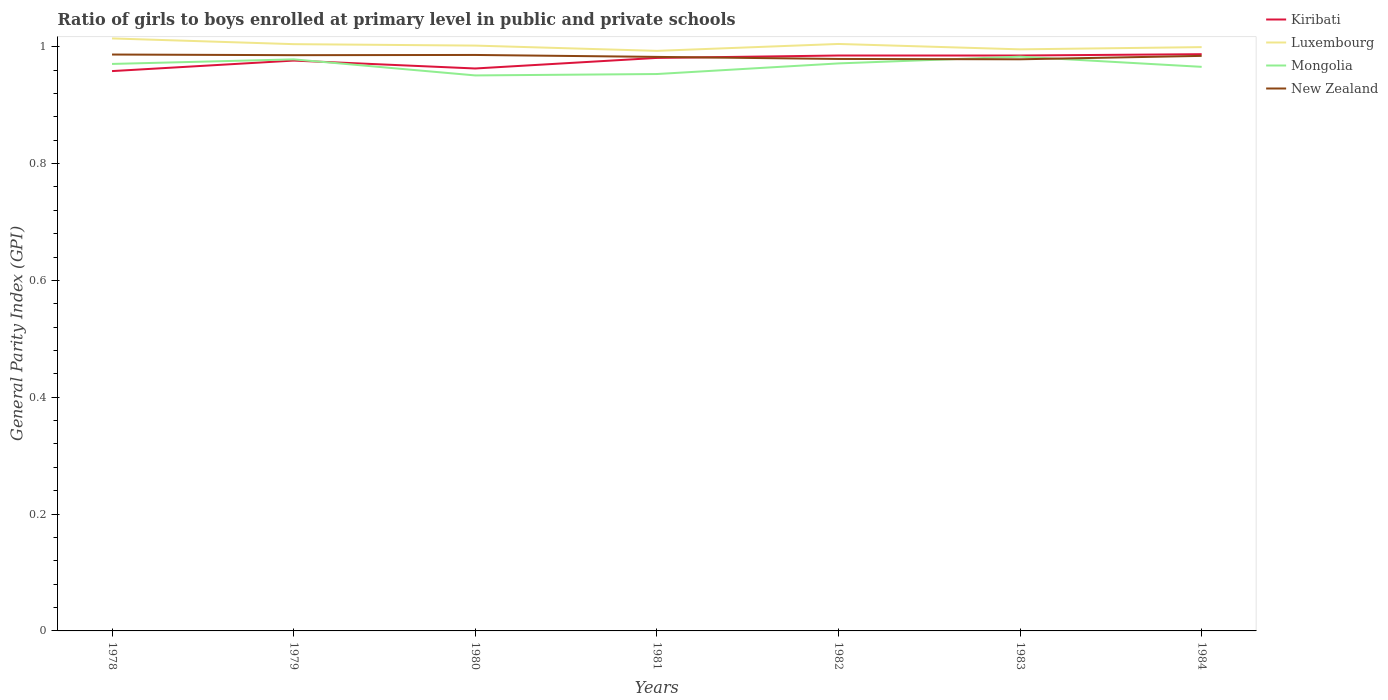How many different coloured lines are there?
Offer a very short reply. 4. Is the number of lines equal to the number of legend labels?
Your answer should be very brief. Yes. Across all years, what is the maximum general parity index in Kiribati?
Your response must be concise. 0.96. What is the total general parity index in Kiribati in the graph?
Keep it short and to the point. -0.03. What is the difference between the highest and the second highest general parity index in Luxembourg?
Give a very brief answer. 0.02. Is the general parity index in New Zealand strictly greater than the general parity index in Kiribati over the years?
Offer a terse response. No. How many lines are there?
Your response must be concise. 4. How many years are there in the graph?
Give a very brief answer. 7. Are the values on the major ticks of Y-axis written in scientific E-notation?
Ensure brevity in your answer.  No. Does the graph contain any zero values?
Ensure brevity in your answer.  No. How many legend labels are there?
Keep it short and to the point. 4. What is the title of the graph?
Offer a very short reply. Ratio of girls to boys enrolled at primary level in public and private schools. Does "Sierra Leone" appear as one of the legend labels in the graph?
Ensure brevity in your answer.  No. What is the label or title of the Y-axis?
Give a very brief answer. General Parity Index (GPI). What is the General Parity Index (GPI) of Kiribati in 1978?
Provide a succinct answer. 0.96. What is the General Parity Index (GPI) of Luxembourg in 1978?
Your answer should be compact. 1.01. What is the General Parity Index (GPI) in Mongolia in 1978?
Your response must be concise. 0.97. What is the General Parity Index (GPI) of New Zealand in 1978?
Provide a short and direct response. 0.99. What is the General Parity Index (GPI) in Kiribati in 1979?
Your answer should be compact. 0.98. What is the General Parity Index (GPI) in Luxembourg in 1979?
Offer a very short reply. 1. What is the General Parity Index (GPI) in Mongolia in 1979?
Your response must be concise. 0.98. What is the General Parity Index (GPI) of New Zealand in 1979?
Ensure brevity in your answer.  0.99. What is the General Parity Index (GPI) of Kiribati in 1980?
Keep it short and to the point. 0.96. What is the General Parity Index (GPI) in Luxembourg in 1980?
Offer a very short reply. 1. What is the General Parity Index (GPI) in Mongolia in 1980?
Your answer should be very brief. 0.95. What is the General Parity Index (GPI) of New Zealand in 1980?
Your answer should be compact. 0.99. What is the General Parity Index (GPI) of Kiribati in 1981?
Your answer should be compact. 0.98. What is the General Parity Index (GPI) of Luxembourg in 1981?
Offer a terse response. 0.99. What is the General Parity Index (GPI) in Mongolia in 1981?
Keep it short and to the point. 0.95. What is the General Parity Index (GPI) of New Zealand in 1981?
Your answer should be compact. 0.98. What is the General Parity Index (GPI) of Kiribati in 1982?
Make the answer very short. 0.98. What is the General Parity Index (GPI) of Luxembourg in 1982?
Keep it short and to the point. 1. What is the General Parity Index (GPI) in Mongolia in 1982?
Make the answer very short. 0.97. What is the General Parity Index (GPI) in New Zealand in 1982?
Your answer should be compact. 0.98. What is the General Parity Index (GPI) of Kiribati in 1983?
Make the answer very short. 0.98. What is the General Parity Index (GPI) of Luxembourg in 1983?
Make the answer very short. 1. What is the General Parity Index (GPI) in Mongolia in 1983?
Make the answer very short. 0.98. What is the General Parity Index (GPI) of New Zealand in 1983?
Keep it short and to the point. 0.98. What is the General Parity Index (GPI) of Kiribati in 1984?
Your response must be concise. 0.99. What is the General Parity Index (GPI) in Luxembourg in 1984?
Provide a succinct answer. 1. What is the General Parity Index (GPI) of Mongolia in 1984?
Provide a short and direct response. 0.97. What is the General Parity Index (GPI) in New Zealand in 1984?
Your answer should be compact. 0.98. Across all years, what is the maximum General Parity Index (GPI) in Kiribati?
Give a very brief answer. 0.99. Across all years, what is the maximum General Parity Index (GPI) in Luxembourg?
Give a very brief answer. 1.01. Across all years, what is the maximum General Parity Index (GPI) of Mongolia?
Ensure brevity in your answer.  0.98. Across all years, what is the maximum General Parity Index (GPI) in New Zealand?
Offer a terse response. 0.99. Across all years, what is the minimum General Parity Index (GPI) in Kiribati?
Your answer should be compact. 0.96. Across all years, what is the minimum General Parity Index (GPI) in Luxembourg?
Provide a succinct answer. 0.99. Across all years, what is the minimum General Parity Index (GPI) of Mongolia?
Offer a very short reply. 0.95. Across all years, what is the minimum General Parity Index (GPI) of New Zealand?
Your answer should be compact. 0.98. What is the total General Parity Index (GPI) of Kiribati in the graph?
Your answer should be compact. 6.83. What is the total General Parity Index (GPI) of Luxembourg in the graph?
Your response must be concise. 7.01. What is the total General Parity Index (GPI) in Mongolia in the graph?
Keep it short and to the point. 6.77. What is the total General Parity Index (GPI) in New Zealand in the graph?
Your answer should be very brief. 6.88. What is the difference between the General Parity Index (GPI) of Kiribati in 1978 and that in 1979?
Keep it short and to the point. -0.02. What is the difference between the General Parity Index (GPI) in Luxembourg in 1978 and that in 1979?
Your response must be concise. 0.01. What is the difference between the General Parity Index (GPI) of Mongolia in 1978 and that in 1979?
Make the answer very short. -0.01. What is the difference between the General Parity Index (GPI) of New Zealand in 1978 and that in 1979?
Your answer should be compact. 0. What is the difference between the General Parity Index (GPI) in Kiribati in 1978 and that in 1980?
Provide a short and direct response. -0. What is the difference between the General Parity Index (GPI) of Luxembourg in 1978 and that in 1980?
Offer a terse response. 0.01. What is the difference between the General Parity Index (GPI) of Mongolia in 1978 and that in 1980?
Your answer should be very brief. 0.02. What is the difference between the General Parity Index (GPI) in New Zealand in 1978 and that in 1980?
Your answer should be very brief. 0. What is the difference between the General Parity Index (GPI) of Kiribati in 1978 and that in 1981?
Ensure brevity in your answer.  -0.02. What is the difference between the General Parity Index (GPI) of Luxembourg in 1978 and that in 1981?
Your answer should be very brief. 0.02. What is the difference between the General Parity Index (GPI) of Mongolia in 1978 and that in 1981?
Provide a short and direct response. 0.02. What is the difference between the General Parity Index (GPI) of New Zealand in 1978 and that in 1981?
Your answer should be very brief. 0. What is the difference between the General Parity Index (GPI) in Kiribati in 1978 and that in 1982?
Your answer should be compact. -0.03. What is the difference between the General Parity Index (GPI) in Luxembourg in 1978 and that in 1982?
Keep it short and to the point. 0.01. What is the difference between the General Parity Index (GPI) in Mongolia in 1978 and that in 1982?
Give a very brief answer. -0. What is the difference between the General Parity Index (GPI) in New Zealand in 1978 and that in 1982?
Provide a short and direct response. 0.01. What is the difference between the General Parity Index (GPI) in Kiribati in 1978 and that in 1983?
Offer a terse response. -0.03. What is the difference between the General Parity Index (GPI) of Luxembourg in 1978 and that in 1983?
Offer a terse response. 0.02. What is the difference between the General Parity Index (GPI) of Mongolia in 1978 and that in 1983?
Your answer should be very brief. -0.01. What is the difference between the General Parity Index (GPI) of New Zealand in 1978 and that in 1983?
Your answer should be compact. 0.01. What is the difference between the General Parity Index (GPI) of Kiribati in 1978 and that in 1984?
Your answer should be compact. -0.03. What is the difference between the General Parity Index (GPI) of Luxembourg in 1978 and that in 1984?
Make the answer very short. 0.01. What is the difference between the General Parity Index (GPI) in Mongolia in 1978 and that in 1984?
Your answer should be compact. 0.01. What is the difference between the General Parity Index (GPI) of New Zealand in 1978 and that in 1984?
Offer a very short reply. 0. What is the difference between the General Parity Index (GPI) in Kiribati in 1979 and that in 1980?
Provide a short and direct response. 0.01. What is the difference between the General Parity Index (GPI) in Luxembourg in 1979 and that in 1980?
Give a very brief answer. 0. What is the difference between the General Parity Index (GPI) in Mongolia in 1979 and that in 1980?
Your answer should be compact. 0.03. What is the difference between the General Parity Index (GPI) of New Zealand in 1979 and that in 1980?
Offer a terse response. -0. What is the difference between the General Parity Index (GPI) of Kiribati in 1979 and that in 1981?
Your answer should be compact. -0. What is the difference between the General Parity Index (GPI) of Luxembourg in 1979 and that in 1981?
Your answer should be compact. 0.01. What is the difference between the General Parity Index (GPI) in Mongolia in 1979 and that in 1981?
Ensure brevity in your answer.  0.03. What is the difference between the General Parity Index (GPI) of New Zealand in 1979 and that in 1981?
Offer a very short reply. 0. What is the difference between the General Parity Index (GPI) of Kiribati in 1979 and that in 1982?
Provide a succinct answer. -0.01. What is the difference between the General Parity Index (GPI) in Luxembourg in 1979 and that in 1982?
Provide a short and direct response. -0. What is the difference between the General Parity Index (GPI) of Mongolia in 1979 and that in 1982?
Your response must be concise. 0.01. What is the difference between the General Parity Index (GPI) in New Zealand in 1979 and that in 1982?
Your response must be concise. 0.01. What is the difference between the General Parity Index (GPI) of Kiribati in 1979 and that in 1983?
Provide a short and direct response. -0.01. What is the difference between the General Parity Index (GPI) of Luxembourg in 1979 and that in 1983?
Provide a succinct answer. 0.01. What is the difference between the General Parity Index (GPI) of Mongolia in 1979 and that in 1983?
Provide a short and direct response. -0. What is the difference between the General Parity Index (GPI) in New Zealand in 1979 and that in 1983?
Ensure brevity in your answer.  0.01. What is the difference between the General Parity Index (GPI) of Kiribati in 1979 and that in 1984?
Provide a short and direct response. -0.01. What is the difference between the General Parity Index (GPI) in Luxembourg in 1979 and that in 1984?
Your answer should be very brief. 0.01. What is the difference between the General Parity Index (GPI) of Mongolia in 1979 and that in 1984?
Keep it short and to the point. 0.01. What is the difference between the General Parity Index (GPI) in New Zealand in 1979 and that in 1984?
Provide a short and direct response. 0. What is the difference between the General Parity Index (GPI) of Kiribati in 1980 and that in 1981?
Offer a very short reply. -0.02. What is the difference between the General Parity Index (GPI) in Luxembourg in 1980 and that in 1981?
Your response must be concise. 0.01. What is the difference between the General Parity Index (GPI) of Mongolia in 1980 and that in 1981?
Give a very brief answer. -0. What is the difference between the General Parity Index (GPI) in New Zealand in 1980 and that in 1981?
Keep it short and to the point. 0. What is the difference between the General Parity Index (GPI) in Kiribati in 1980 and that in 1982?
Give a very brief answer. -0.02. What is the difference between the General Parity Index (GPI) in Luxembourg in 1980 and that in 1982?
Keep it short and to the point. -0. What is the difference between the General Parity Index (GPI) of Mongolia in 1980 and that in 1982?
Make the answer very short. -0.02. What is the difference between the General Parity Index (GPI) of New Zealand in 1980 and that in 1982?
Provide a succinct answer. 0.01. What is the difference between the General Parity Index (GPI) of Kiribati in 1980 and that in 1983?
Offer a very short reply. -0.02. What is the difference between the General Parity Index (GPI) of Luxembourg in 1980 and that in 1983?
Give a very brief answer. 0.01. What is the difference between the General Parity Index (GPI) of Mongolia in 1980 and that in 1983?
Provide a succinct answer. -0.03. What is the difference between the General Parity Index (GPI) in New Zealand in 1980 and that in 1983?
Ensure brevity in your answer.  0.01. What is the difference between the General Parity Index (GPI) in Kiribati in 1980 and that in 1984?
Your answer should be very brief. -0.02. What is the difference between the General Parity Index (GPI) in Luxembourg in 1980 and that in 1984?
Offer a very short reply. 0. What is the difference between the General Parity Index (GPI) of Mongolia in 1980 and that in 1984?
Make the answer very short. -0.01. What is the difference between the General Parity Index (GPI) in New Zealand in 1980 and that in 1984?
Give a very brief answer. 0. What is the difference between the General Parity Index (GPI) of Kiribati in 1981 and that in 1982?
Your answer should be compact. -0. What is the difference between the General Parity Index (GPI) in Luxembourg in 1981 and that in 1982?
Give a very brief answer. -0.01. What is the difference between the General Parity Index (GPI) of Mongolia in 1981 and that in 1982?
Keep it short and to the point. -0.02. What is the difference between the General Parity Index (GPI) of New Zealand in 1981 and that in 1982?
Keep it short and to the point. 0. What is the difference between the General Parity Index (GPI) in Kiribati in 1981 and that in 1983?
Your response must be concise. -0. What is the difference between the General Parity Index (GPI) in Luxembourg in 1981 and that in 1983?
Keep it short and to the point. -0. What is the difference between the General Parity Index (GPI) in Mongolia in 1981 and that in 1983?
Ensure brevity in your answer.  -0.03. What is the difference between the General Parity Index (GPI) in New Zealand in 1981 and that in 1983?
Ensure brevity in your answer.  0. What is the difference between the General Parity Index (GPI) in Kiribati in 1981 and that in 1984?
Your answer should be compact. -0.01. What is the difference between the General Parity Index (GPI) of Luxembourg in 1981 and that in 1984?
Your answer should be compact. -0.01. What is the difference between the General Parity Index (GPI) of Mongolia in 1981 and that in 1984?
Your answer should be very brief. -0.01. What is the difference between the General Parity Index (GPI) in New Zealand in 1981 and that in 1984?
Make the answer very short. -0. What is the difference between the General Parity Index (GPI) of Kiribati in 1982 and that in 1983?
Your answer should be very brief. -0. What is the difference between the General Parity Index (GPI) in Luxembourg in 1982 and that in 1983?
Provide a succinct answer. 0.01. What is the difference between the General Parity Index (GPI) in Mongolia in 1982 and that in 1983?
Keep it short and to the point. -0.01. What is the difference between the General Parity Index (GPI) of New Zealand in 1982 and that in 1983?
Provide a short and direct response. 0. What is the difference between the General Parity Index (GPI) of Kiribati in 1982 and that in 1984?
Your answer should be very brief. -0. What is the difference between the General Parity Index (GPI) of Luxembourg in 1982 and that in 1984?
Your answer should be very brief. 0.01. What is the difference between the General Parity Index (GPI) of Mongolia in 1982 and that in 1984?
Offer a terse response. 0.01. What is the difference between the General Parity Index (GPI) of New Zealand in 1982 and that in 1984?
Provide a short and direct response. -0.01. What is the difference between the General Parity Index (GPI) of Kiribati in 1983 and that in 1984?
Offer a very short reply. -0. What is the difference between the General Parity Index (GPI) of Luxembourg in 1983 and that in 1984?
Your response must be concise. -0. What is the difference between the General Parity Index (GPI) in Mongolia in 1983 and that in 1984?
Offer a terse response. 0.02. What is the difference between the General Parity Index (GPI) in New Zealand in 1983 and that in 1984?
Keep it short and to the point. -0.01. What is the difference between the General Parity Index (GPI) of Kiribati in 1978 and the General Parity Index (GPI) of Luxembourg in 1979?
Offer a terse response. -0.05. What is the difference between the General Parity Index (GPI) of Kiribati in 1978 and the General Parity Index (GPI) of Mongolia in 1979?
Your answer should be compact. -0.02. What is the difference between the General Parity Index (GPI) of Kiribati in 1978 and the General Parity Index (GPI) of New Zealand in 1979?
Your response must be concise. -0.03. What is the difference between the General Parity Index (GPI) in Luxembourg in 1978 and the General Parity Index (GPI) in Mongolia in 1979?
Provide a succinct answer. 0.04. What is the difference between the General Parity Index (GPI) in Luxembourg in 1978 and the General Parity Index (GPI) in New Zealand in 1979?
Offer a very short reply. 0.03. What is the difference between the General Parity Index (GPI) of Mongolia in 1978 and the General Parity Index (GPI) of New Zealand in 1979?
Your response must be concise. -0.01. What is the difference between the General Parity Index (GPI) of Kiribati in 1978 and the General Parity Index (GPI) of Luxembourg in 1980?
Ensure brevity in your answer.  -0.04. What is the difference between the General Parity Index (GPI) of Kiribati in 1978 and the General Parity Index (GPI) of Mongolia in 1980?
Provide a short and direct response. 0.01. What is the difference between the General Parity Index (GPI) in Kiribati in 1978 and the General Parity Index (GPI) in New Zealand in 1980?
Offer a very short reply. -0.03. What is the difference between the General Parity Index (GPI) of Luxembourg in 1978 and the General Parity Index (GPI) of Mongolia in 1980?
Your answer should be very brief. 0.06. What is the difference between the General Parity Index (GPI) of Luxembourg in 1978 and the General Parity Index (GPI) of New Zealand in 1980?
Your answer should be very brief. 0.03. What is the difference between the General Parity Index (GPI) in Mongolia in 1978 and the General Parity Index (GPI) in New Zealand in 1980?
Your answer should be very brief. -0.02. What is the difference between the General Parity Index (GPI) of Kiribati in 1978 and the General Parity Index (GPI) of Luxembourg in 1981?
Your answer should be very brief. -0.03. What is the difference between the General Parity Index (GPI) of Kiribati in 1978 and the General Parity Index (GPI) of Mongolia in 1981?
Provide a short and direct response. 0.01. What is the difference between the General Parity Index (GPI) in Kiribati in 1978 and the General Parity Index (GPI) in New Zealand in 1981?
Give a very brief answer. -0.02. What is the difference between the General Parity Index (GPI) of Luxembourg in 1978 and the General Parity Index (GPI) of Mongolia in 1981?
Ensure brevity in your answer.  0.06. What is the difference between the General Parity Index (GPI) of Luxembourg in 1978 and the General Parity Index (GPI) of New Zealand in 1981?
Keep it short and to the point. 0.03. What is the difference between the General Parity Index (GPI) of Mongolia in 1978 and the General Parity Index (GPI) of New Zealand in 1981?
Make the answer very short. -0.01. What is the difference between the General Parity Index (GPI) of Kiribati in 1978 and the General Parity Index (GPI) of Luxembourg in 1982?
Your answer should be very brief. -0.05. What is the difference between the General Parity Index (GPI) of Kiribati in 1978 and the General Parity Index (GPI) of Mongolia in 1982?
Keep it short and to the point. -0.01. What is the difference between the General Parity Index (GPI) in Kiribati in 1978 and the General Parity Index (GPI) in New Zealand in 1982?
Your response must be concise. -0.02. What is the difference between the General Parity Index (GPI) of Luxembourg in 1978 and the General Parity Index (GPI) of Mongolia in 1982?
Your answer should be very brief. 0.04. What is the difference between the General Parity Index (GPI) in Luxembourg in 1978 and the General Parity Index (GPI) in New Zealand in 1982?
Offer a very short reply. 0.04. What is the difference between the General Parity Index (GPI) of Mongolia in 1978 and the General Parity Index (GPI) of New Zealand in 1982?
Offer a terse response. -0.01. What is the difference between the General Parity Index (GPI) of Kiribati in 1978 and the General Parity Index (GPI) of Luxembourg in 1983?
Offer a terse response. -0.04. What is the difference between the General Parity Index (GPI) of Kiribati in 1978 and the General Parity Index (GPI) of Mongolia in 1983?
Give a very brief answer. -0.02. What is the difference between the General Parity Index (GPI) of Kiribati in 1978 and the General Parity Index (GPI) of New Zealand in 1983?
Keep it short and to the point. -0.02. What is the difference between the General Parity Index (GPI) of Luxembourg in 1978 and the General Parity Index (GPI) of Mongolia in 1983?
Your answer should be very brief. 0.03. What is the difference between the General Parity Index (GPI) in Luxembourg in 1978 and the General Parity Index (GPI) in New Zealand in 1983?
Ensure brevity in your answer.  0.04. What is the difference between the General Parity Index (GPI) of Mongolia in 1978 and the General Parity Index (GPI) of New Zealand in 1983?
Provide a succinct answer. -0.01. What is the difference between the General Parity Index (GPI) of Kiribati in 1978 and the General Parity Index (GPI) of Luxembourg in 1984?
Your answer should be compact. -0.04. What is the difference between the General Parity Index (GPI) of Kiribati in 1978 and the General Parity Index (GPI) of Mongolia in 1984?
Ensure brevity in your answer.  -0.01. What is the difference between the General Parity Index (GPI) in Kiribati in 1978 and the General Parity Index (GPI) in New Zealand in 1984?
Offer a terse response. -0.03. What is the difference between the General Parity Index (GPI) of Luxembourg in 1978 and the General Parity Index (GPI) of Mongolia in 1984?
Offer a terse response. 0.05. What is the difference between the General Parity Index (GPI) of Luxembourg in 1978 and the General Parity Index (GPI) of New Zealand in 1984?
Provide a short and direct response. 0.03. What is the difference between the General Parity Index (GPI) of Mongolia in 1978 and the General Parity Index (GPI) of New Zealand in 1984?
Your response must be concise. -0.01. What is the difference between the General Parity Index (GPI) in Kiribati in 1979 and the General Parity Index (GPI) in Luxembourg in 1980?
Provide a succinct answer. -0.03. What is the difference between the General Parity Index (GPI) in Kiribati in 1979 and the General Parity Index (GPI) in Mongolia in 1980?
Offer a very short reply. 0.03. What is the difference between the General Parity Index (GPI) in Kiribati in 1979 and the General Parity Index (GPI) in New Zealand in 1980?
Your answer should be compact. -0.01. What is the difference between the General Parity Index (GPI) in Luxembourg in 1979 and the General Parity Index (GPI) in Mongolia in 1980?
Your response must be concise. 0.05. What is the difference between the General Parity Index (GPI) of Luxembourg in 1979 and the General Parity Index (GPI) of New Zealand in 1980?
Provide a succinct answer. 0.02. What is the difference between the General Parity Index (GPI) of Mongolia in 1979 and the General Parity Index (GPI) of New Zealand in 1980?
Provide a succinct answer. -0.01. What is the difference between the General Parity Index (GPI) of Kiribati in 1979 and the General Parity Index (GPI) of Luxembourg in 1981?
Provide a short and direct response. -0.02. What is the difference between the General Parity Index (GPI) of Kiribati in 1979 and the General Parity Index (GPI) of Mongolia in 1981?
Your response must be concise. 0.02. What is the difference between the General Parity Index (GPI) of Kiribati in 1979 and the General Parity Index (GPI) of New Zealand in 1981?
Offer a terse response. -0.01. What is the difference between the General Parity Index (GPI) of Luxembourg in 1979 and the General Parity Index (GPI) of Mongolia in 1981?
Your answer should be compact. 0.05. What is the difference between the General Parity Index (GPI) in Luxembourg in 1979 and the General Parity Index (GPI) in New Zealand in 1981?
Give a very brief answer. 0.02. What is the difference between the General Parity Index (GPI) of Mongolia in 1979 and the General Parity Index (GPI) of New Zealand in 1981?
Your answer should be very brief. -0. What is the difference between the General Parity Index (GPI) of Kiribati in 1979 and the General Parity Index (GPI) of Luxembourg in 1982?
Your answer should be compact. -0.03. What is the difference between the General Parity Index (GPI) of Kiribati in 1979 and the General Parity Index (GPI) of Mongolia in 1982?
Your response must be concise. 0. What is the difference between the General Parity Index (GPI) of Kiribati in 1979 and the General Parity Index (GPI) of New Zealand in 1982?
Offer a terse response. -0. What is the difference between the General Parity Index (GPI) in Luxembourg in 1979 and the General Parity Index (GPI) in Mongolia in 1982?
Your response must be concise. 0.03. What is the difference between the General Parity Index (GPI) of Luxembourg in 1979 and the General Parity Index (GPI) of New Zealand in 1982?
Offer a terse response. 0.03. What is the difference between the General Parity Index (GPI) of Mongolia in 1979 and the General Parity Index (GPI) of New Zealand in 1982?
Keep it short and to the point. -0. What is the difference between the General Parity Index (GPI) in Kiribati in 1979 and the General Parity Index (GPI) in Luxembourg in 1983?
Make the answer very short. -0.02. What is the difference between the General Parity Index (GPI) in Kiribati in 1979 and the General Parity Index (GPI) in Mongolia in 1983?
Provide a succinct answer. -0.01. What is the difference between the General Parity Index (GPI) in Kiribati in 1979 and the General Parity Index (GPI) in New Zealand in 1983?
Keep it short and to the point. -0. What is the difference between the General Parity Index (GPI) of Luxembourg in 1979 and the General Parity Index (GPI) of Mongolia in 1983?
Give a very brief answer. 0.02. What is the difference between the General Parity Index (GPI) of Luxembourg in 1979 and the General Parity Index (GPI) of New Zealand in 1983?
Offer a terse response. 0.03. What is the difference between the General Parity Index (GPI) in Mongolia in 1979 and the General Parity Index (GPI) in New Zealand in 1983?
Your answer should be very brief. -0. What is the difference between the General Parity Index (GPI) of Kiribati in 1979 and the General Parity Index (GPI) of Luxembourg in 1984?
Your answer should be compact. -0.02. What is the difference between the General Parity Index (GPI) in Kiribati in 1979 and the General Parity Index (GPI) in Mongolia in 1984?
Your answer should be very brief. 0.01. What is the difference between the General Parity Index (GPI) of Kiribati in 1979 and the General Parity Index (GPI) of New Zealand in 1984?
Ensure brevity in your answer.  -0.01. What is the difference between the General Parity Index (GPI) of Luxembourg in 1979 and the General Parity Index (GPI) of Mongolia in 1984?
Provide a succinct answer. 0.04. What is the difference between the General Parity Index (GPI) in Luxembourg in 1979 and the General Parity Index (GPI) in New Zealand in 1984?
Your response must be concise. 0.02. What is the difference between the General Parity Index (GPI) of Mongolia in 1979 and the General Parity Index (GPI) of New Zealand in 1984?
Provide a succinct answer. -0.01. What is the difference between the General Parity Index (GPI) of Kiribati in 1980 and the General Parity Index (GPI) of Luxembourg in 1981?
Your answer should be very brief. -0.03. What is the difference between the General Parity Index (GPI) in Kiribati in 1980 and the General Parity Index (GPI) in Mongolia in 1981?
Keep it short and to the point. 0.01. What is the difference between the General Parity Index (GPI) of Kiribati in 1980 and the General Parity Index (GPI) of New Zealand in 1981?
Keep it short and to the point. -0.02. What is the difference between the General Parity Index (GPI) in Luxembourg in 1980 and the General Parity Index (GPI) in Mongolia in 1981?
Give a very brief answer. 0.05. What is the difference between the General Parity Index (GPI) of Luxembourg in 1980 and the General Parity Index (GPI) of New Zealand in 1981?
Your answer should be very brief. 0.02. What is the difference between the General Parity Index (GPI) in Mongolia in 1980 and the General Parity Index (GPI) in New Zealand in 1981?
Your answer should be very brief. -0.03. What is the difference between the General Parity Index (GPI) in Kiribati in 1980 and the General Parity Index (GPI) in Luxembourg in 1982?
Offer a very short reply. -0.04. What is the difference between the General Parity Index (GPI) of Kiribati in 1980 and the General Parity Index (GPI) of Mongolia in 1982?
Keep it short and to the point. -0.01. What is the difference between the General Parity Index (GPI) of Kiribati in 1980 and the General Parity Index (GPI) of New Zealand in 1982?
Make the answer very short. -0.02. What is the difference between the General Parity Index (GPI) of Luxembourg in 1980 and the General Parity Index (GPI) of Mongolia in 1982?
Your answer should be very brief. 0.03. What is the difference between the General Parity Index (GPI) in Luxembourg in 1980 and the General Parity Index (GPI) in New Zealand in 1982?
Keep it short and to the point. 0.02. What is the difference between the General Parity Index (GPI) in Mongolia in 1980 and the General Parity Index (GPI) in New Zealand in 1982?
Your response must be concise. -0.03. What is the difference between the General Parity Index (GPI) in Kiribati in 1980 and the General Parity Index (GPI) in Luxembourg in 1983?
Your answer should be very brief. -0.03. What is the difference between the General Parity Index (GPI) of Kiribati in 1980 and the General Parity Index (GPI) of Mongolia in 1983?
Your answer should be very brief. -0.02. What is the difference between the General Parity Index (GPI) in Kiribati in 1980 and the General Parity Index (GPI) in New Zealand in 1983?
Provide a succinct answer. -0.02. What is the difference between the General Parity Index (GPI) of Luxembourg in 1980 and the General Parity Index (GPI) of Mongolia in 1983?
Give a very brief answer. 0.02. What is the difference between the General Parity Index (GPI) of Luxembourg in 1980 and the General Parity Index (GPI) of New Zealand in 1983?
Ensure brevity in your answer.  0.02. What is the difference between the General Parity Index (GPI) of Mongolia in 1980 and the General Parity Index (GPI) of New Zealand in 1983?
Provide a short and direct response. -0.03. What is the difference between the General Parity Index (GPI) of Kiribati in 1980 and the General Parity Index (GPI) of Luxembourg in 1984?
Offer a very short reply. -0.04. What is the difference between the General Parity Index (GPI) of Kiribati in 1980 and the General Parity Index (GPI) of Mongolia in 1984?
Make the answer very short. -0. What is the difference between the General Parity Index (GPI) of Kiribati in 1980 and the General Parity Index (GPI) of New Zealand in 1984?
Provide a short and direct response. -0.02. What is the difference between the General Parity Index (GPI) of Luxembourg in 1980 and the General Parity Index (GPI) of Mongolia in 1984?
Ensure brevity in your answer.  0.04. What is the difference between the General Parity Index (GPI) of Luxembourg in 1980 and the General Parity Index (GPI) of New Zealand in 1984?
Your answer should be compact. 0.02. What is the difference between the General Parity Index (GPI) in Mongolia in 1980 and the General Parity Index (GPI) in New Zealand in 1984?
Provide a short and direct response. -0.03. What is the difference between the General Parity Index (GPI) in Kiribati in 1981 and the General Parity Index (GPI) in Luxembourg in 1982?
Offer a terse response. -0.02. What is the difference between the General Parity Index (GPI) of Kiribati in 1981 and the General Parity Index (GPI) of Mongolia in 1982?
Give a very brief answer. 0.01. What is the difference between the General Parity Index (GPI) in Kiribati in 1981 and the General Parity Index (GPI) in New Zealand in 1982?
Give a very brief answer. 0. What is the difference between the General Parity Index (GPI) in Luxembourg in 1981 and the General Parity Index (GPI) in Mongolia in 1982?
Ensure brevity in your answer.  0.02. What is the difference between the General Parity Index (GPI) in Luxembourg in 1981 and the General Parity Index (GPI) in New Zealand in 1982?
Make the answer very short. 0.01. What is the difference between the General Parity Index (GPI) of Mongolia in 1981 and the General Parity Index (GPI) of New Zealand in 1982?
Give a very brief answer. -0.03. What is the difference between the General Parity Index (GPI) of Kiribati in 1981 and the General Parity Index (GPI) of Luxembourg in 1983?
Give a very brief answer. -0.01. What is the difference between the General Parity Index (GPI) in Kiribati in 1981 and the General Parity Index (GPI) in Mongolia in 1983?
Your answer should be very brief. -0. What is the difference between the General Parity Index (GPI) of Kiribati in 1981 and the General Parity Index (GPI) of New Zealand in 1983?
Offer a very short reply. 0. What is the difference between the General Parity Index (GPI) of Luxembourg in 1981 and the General Parity Index (GPI) of Mongolia in 1983?
Keep it short and to the point. 0.01. What is the difference between the General Parity Index (GPI) in Luxembourg in 1981 and the General Parity Index (GPI) in New Zealand in 1983?
Your response must be concise. 0.01. What is the difference between the General Parity Index (GPI) of Mongolia in 1981 and the General Parity Index (GPI) of New Zealand in 1983?
Make the answer very short. -0.03. What is the difference between the General Parity Index (GPI) of Kiribati in 1981 and the General Parity Index (GPI) of Luxembourg in 1984?
Offer a terse response. -0.02. What is the difference between the General Parity Index (GPI) in Kiribati in 1981 and the General Parity Index (GPI) in Mongolia in 1984?
Your response must be concise. 0.02. What is the difference between the General Parity Index (GPI) in Kiribati in 1981 and the General Parity Index (GPI) in New Zealand in 1984?
Offer a terse response. -0. What is the difference between the General Parity Index (GPI) of Luxembourg in 1981 and the General Parity Index (GPI) of Mongolia in 1984?
Provide a succinct answer. 0.03. What is the difference between the General Parity Index (GPI) in Luxembourg in 1981 and the General Parity Index (GPI) in New Zealand in 1984?
Your answer should be very brief. 0.01. What is the difference between the General Parity Index (GPI) in Mongolia in 1981 and the General Parity Index (GPI) in New Zealand in 1984?
Offer a terse response. -0.03. What is the difference between the General Parity Index (GPI) in Kiribati in 1982 and the General Parity Index (GPI) in Luxembourg in 1983?
Give a very brief answer. -0.01. What is the difference between the General Parity Index (GPI) of Kiribati in 1982 and the General Parity Index (GPI) of Mongolia in 1983?
Give a very brief answer. 0. What is the difference between the General Parity Index (GPI) in Kiribati in 1982 and the General Parity Index (GPI) in New Zealand in 1983?
Provide a succinct answer. 0.01. What is the difference between the General Parity Index (GPI) in Luxembourg in 1982 and the General Parity Index (GPI) in Mongolia in 1983?
Offer a very short reply. 0.02. What is the difference between the General Parity Index (GPI) in Luxembourg in 1982 and the General Parity Index (GPI) in New Zealand in 1983?
Provide a succinct answer. 0.03. What is the difference between the General Parity Index (GPI) in Mongolia in 1982 and the General Parity Index (GPI) in New Zealand in 1983?
Provide a short and direct response. -0.01. What is the difference between the General Parity Index (GPI) of Kiribati in 1982 and the General Parity Index (GPI) of Luxembourg in 1984?
Provide a succinct answer. -0.01. What is the difference between the General Parity Index (GPI) of Kiribati in 1982 and the General Parity Index (GPI) of Mongolia in 1984?
Your answer should be compact. 0.02. What is the difference between the General Parity Index (GPI) in Kiribati in 1982 and the General Parity Index (GPI) in New Zealand in 1984?
Keep it short and to the point. 0. What is the difference between the General Parity Index (GPI) in Luxembourg in 1982 and the General Parity Index (GPI) in Mongolia in 1984?
Your response must be concise. 0.04. What is the difference between the General Parity Index (GPI) of Luxembourg in 1982 and the General Parity Index (GPI) of New Zealand in 1984?
Your answer should be compact. 0.02. What is the difference between the General Parity Index (GPI) in Mongolia in 1982 and the General Parity Index (GPI) in New Zealand in 1984?
Provide a succinct answer. -0.01. What is the difference between the General Parity Index (GPI) of Kiribati in 1983 and the General Parity Index (GPI) of Luxembourg in 1984?
Your answer should be compact. -0.01. What is the difference between the General Parity Index (GPI) in Kiribati in 1983 and the General Parity Index (GPI) in Mongolia in 1984?
Provide a succinct answer. 0.02. What is the difference between the General Parity Index (GPI) of Kiribati in 1983 and the General Parity Index (GPI) of New Zealand in 1984?
Provide a short and direct response. 0. What is the difference between the General Parity Index (GPI) in Luxembourg in 1983 and the General Parity Index (GPI) in New Zealand in 1984?
Offer a very short reply. 0.01. What is the difference between the General Parity Index (GPI) of Mongolia in 1983 and the General Parity Index (GPI) of New Zealand in 1984?
Offer a terse response. -0. What is the average General Parity Index (GPI) of Kiribati per year?
Provide a short and direct response. 0.98. What is the average General Parity Index (GPI) in Mongolia per year?
Provide a short and direct response. 0.97. What is the average General Parity Index (GPI) in New Zealand per year?
Provide a succinct answer. 0.98. In the year 1978, what is the difference between the General Parity Index (GPI) of Kiribati and General Parity Index (GPI) of Luxembourg?
Provide a succinct answer. -0.06. In the year 1978, what is the difference between the General Parity Index (GPI) in Kiribati and General Parity Index (GPI) in Mongolia?
Offer a very short reply. -0.01. In the year 1978, what is the difference between the General Parity Index (GPI) of Kiribati and General Parity Index (GPI) of New Zealand?
Keep it short and to the point. -0.03. In the year 1978, what is the difference between the General Parity Index (GPI) of Luxembourg and General Parity Index (GPI) of Mongolia?
Make the answer very short. 0.04. In the year 1978, what is the difference between the General Parity Index (GPI) of Luxembourg and General Parity Index (GPI) of New Zealand?
Keep it short and to the point. 0.03. In the year 1978, what is the difference between the General Parity Index (GPI) of Mongolia and General Parity Index (GPI) of New Zealand?
Your answer should be very brief. -0.02. In the year 1979, what is the difference between the General Parity Index (GPI) of Kiribati and General Parity Index (GPI) of Luxembourg?
Your answer should be compact. -0.03. In the year 1979, what is the difference between the General Parity Index (GPI) in Kiribati and General Parity Index (GPI) in Mongolia?
Ensure brevity in your answer.  -0. In the year 1979, what is the difference between the General Parity Index (GPI) in Kiribati and General Parity Index (GPI) in New Zealand?
Give a very brief answer. -0.01. In the year 1979, what is the difference between the General Parity Index (GPI) of Luxembourg and General Parity Index (GPI) of Mongolia?
Your response must be concise. 0.03. In the year 1979, what is the difference between the General Parity Index (GPI) of Luxembourg and General Parity Index (GPI) of New Zealand?
Keep it short and to the point. 0.02. In the year 1979, what is the difference between the General Parity Index (GPI) of Mongolia and General Parity Index (GPI) of New Zealand?
Your response must be concise. -0.01. In the year 1980, what is the difference between the General Parity Index (GPI) in Kiribati and General Parity Index (GPI) in Luxembourg?
Offer a terse response. -0.04. In the year 1980, what is the difference between the General Parity Index (GPI) of Kiribati and General Parity Index (GPI) of Mongolia?
Make the answer very short. 0.01. In the year 1980, what is the difference between the General Parity Index (GPI) in Kiribati and General Parity Index (GPI) in New Zealand?
Give a very brief answer. -0.02. In the year 1980, what is the difference between the General Parity Index (GPI) of Luxembourg and General Parity Index (GPI) of Mongolia?
Make the answer very short. 0.05. In the year 1980, what is the difference between the General Parity Index (GPI) in Luxembourg and General Parity Index (GPI) in New Zealand?
Keep it short and to the point. 0.02. In the year 1980, what is the difference between the General Parity Index (GPI) of Mongolia and General Parity Index (GPI) of New Zealand?
Offer a very short reply. -0.04. In the year 1981, what is the difference between the General Parity Index (GPI) of Kiribati and General Parity Index (GPI) of Luxembourg?
Offer a terse response. -0.01. In the year 1981, what is the difference between the General Parity Index (GPI) in Kiribati and General Parity Index (GPI) in Mongolia?
Your answer should be very brief. 0.03. In the year 1981, what is the difference between the General Parity Index (GPI) of Kiribati and General Parity Index (GPI) of New Zealand?
Ensure brevity in your answer.  -0. In the year 1981, what is the difference between the General Parity Index (GPI) of Luxembourg and General Parity Index (GPI) of Mongolia?
Your answer should be compact. 0.04. In the year 1981, what is the difference between the General Parity Index (GPI) in Luxembourg and General Parity Index (GPI) in New Zealand?
Provide a succinct answer. 0.01. In the year 1981, what is the difference between the General Parity Index (GPI) of Mongolia and General Parity Index (GPI) of New Zealand?
Your answer should be compact. -0.03. In the year 1982, what is the difference between the General Parity Index (GPI) in Kiribati and General Parity Index (GPI) in Luxembourg?
Ensure brevity in your answer.  -0.02. In the year 1982, what is the difference between the General Parity Index (GPI) in Kiribati and General Parity Index (GPI) in Mongolia?
Make the answer very short. 0.01. In the year 1982, what is the difference between the General Parity Index (GPI) of Kiribati and General Parity Index (GPI) of New Zealand?
Your answer should be very brief. 0.01. In the year 1982, what is the difference between the General Parity Index (GPI) of Luxembourg and General Parity Index (GPI) of New Zealand?
Offer a terse response. 0.03. In the year 1982, what is the difference between the General Parity Index (GPI) in Mongolia and General Parity Index (GPI) in New Zealand?
Give a very brief answer. -0.01. In the year 1983, what is the difference between the General Parity Index (GPI) in Kiribati and General Parity Index (GPI) in Luxembourg?
Offer a very short reply. -0.01. In the year 1983, what is the difference between the General Parity Index (GPI) in Kiribati and General Parity Index (GPI) in Mongolia?
Your response must be concise. 0. In the year 1983, what is the difference between the General Parity Index (GPI) of Kiribati and General Parity Index (GPI) of New Zealand?
Keep it short and to the point. 0.01. In the year 1983, what is the difference between the General Parity Index (GPI) of Luxembourg and General Parity Index (GPI) of Mongolia?
Your response must be concise. 0.01. In the year 1983, what is the difference between the General Parity Index (GPI) of Luxembourg and General Parity Index (GPI) of New Zealand?
Provide a short and direct response. 0.02. In the year 1983, what is the difference between the General Parity Index (GPI) in Mongolia and General Parity Index (GPI) in New Zealand?
Your answer should be compact. 0. In the year 1984, what is the difference between the General Parity Index (GPI) in Kiribati and General Parity Index (GPI) in Luxembourg?
Keep it short and to the point. -0.01. In the year 1984, what is the difference between the General Parity Index (GPI) in Kiribati and General Parity Index (GPI) in Mongolia?
Your response must be concise. 0.02. In the year 1984, what is the difference between the General Parity Index (GPI) in Kiribati and General Parity Index (GPI) in New Zealand?
Your response must be concise. 0. In the year 1984, what is the difference between the General Parity Index (GPI) of Luxembourg and General Parity Index (GPI) of Mongolia?
Keep it short and to the point. 0.03. In the year 1984, what is the difference between the General Parity Index (GPI) in Luxembourg and General Parity Index (GPI) in New Zealand?
Offer a very short reply. 0.01. In the year 1984, what is the difference between the General Parity Index (GPI) of Mongolia and General Parity Index (GPI) of New Zealand?
Provide a short and direct response. -0.02. What is the ratio of the General Parity Index (GPI) of Kiribati in 1978 to that in 1979?
Offer a very short reply. 0.98. What is the ratio of the General Parity Index (GPI) of Luxembourg in 1978 to that in 1979?
Provide a short and direct response. 1.01. What is the ratio of the General Parity Index (GPI) in Kiribati in 1978 to that in 1980?
Offer a very short reply. 1. What is the ratio of the General Parity Index (GPI) in Luxembourg in 1978 to that in 1980?
Offer a terse response. 1.01. What is the ratio of the General Parity Index (GPI) in Mongolia in 1978 to that in 1980?
Give a very brief answer. 1.02. What is the ratio of the General Parity Index (GPI) in Luxembourg in 1978 to that in 1981?
Make the answer very short. 1.02. What is the ratio of the General Parity Index (GPI) of Mongolia in 1978 to that in 1981?
Offer a very short reply. 1.02. What is the ratio of the General Parity Index (GPI) of Kiribati in 1978 to that in 1982?
Ensure brevity in your answer.  0.97. What is the ratio of the General Parity Index (GPI) of Luxembourg in 1978 to that in 1982?
Your response must be concise. 1.01. What is the ratio of the General Parity Index (GPI) in Mongolia in 1978 to that in 1982?
Give a very brief answer. 1. What is the ratio of the General Parity Index (GPI) in New Zealand in 1978 to that in 1982?
Ensure brevity in your answer.  1.01. What is the ratio of the General Parity Index (GPI) of Kiribati in 1978 to that in 1983?
Make the answer very short. 0.97. What is the ratio of the General Parity Index (GPI) of Luxembourg in 1978 to that in 1983?
Provide a short and direct response. 1.02. What is the ratio of the General Parity Index (GPI) in Mongolia in 1978 to that in 1983?
Offer a very short reply. 0.99. What is the ratio of the General Parity Index (GPI) of New Zealand in 1978 to that in 1983?
Your answer should be very brief. 1.01. What is the ratio of the General Parity Index (GPI) in Kiribati in 1978 to that in 1984?
Keep it short and to the point. 0.97. What is the ratio of the General Parity Index (GPI) of Luxembourg in 1978 to that in 1984?
Provide a short and direct response. 1.01. What is the ratio of the General Parity Index (GPI) of Mongolia in 1978 to that in 1984?
Give a very brief answer. 1.01. What is the ratio of the General Parity Index (GPI) of New Zealand in 1978 to that in 1984?
Offer a terse response. 1. What is the ratio of the General Parity Index (GPI) of Kiribati in 1979 to that in 1980?
Offer a terse response. 1.01. What is the ratio of the General Parity Index (GPI) of Mongolia in 1979 to that in 1980?
Offer a terse response. 1.03. What is the ratio of the General Parity Index (GPI) in New Zealand in 1979 to that in 1980?
Your answer should be compact. 1. What is the ratio of the General Parity Index (GPI) of Luxembourg in 1979 to that in 1981?
Give a very brief answer. 1.01. What is the ratio of the General Parity Index (GPI) in Mongolia in 1979 to that in 1981?
Provide a succinct answer. 1.03. What is the ratio of the General Parity Index (GPI) of New Zealand in 1979 to that in 1981?
Provide a short and direct response. 1. What is the ratio of the General Parity Index (GPI) in Kiribati in 1979 to that in 1982?
Offer a terse response. 0.99. What is the ratio of the General Parity Index (GPI) of New Zealand in 1979 to that in 1982?
Make the answer very short. 1.01. What is the ratio of the General Parity Index (GPI) of Luxembourg in 1979 to that in 1983?
Make the answer very short. 1.01. What is the ratio of the General Parity Index (GPI) in New Zealand in 1979 to that in 1983?
Ensure brevity in your answer.  1.01. What is the ratio of the General Parity Index (GPI) in Kiribati in 1979 to that in 1984?
Your response must be concise. 0.99. What is the ratio of the General Parity Index (GPI) of Mongolia in 1979 to that in 1984?
Make the answer very short. 1.01. What is the ratio of the General Parity Index (GPI) in Kiribati in 1980 to that in 1981?
Provide a succinct answer. 0.98. What is the ratio of the General Parity Index (GPI) in Luxembourg in 1980 to that in 1981?
Your answer should be very brief. 1.01. What is the ratio of the General Parity Index (GPI) in New Zealand in 1980 to that in 1981?
Offer a very short reply. 1. What is the ratio of the General Parity Index (GPI) in Kiribati in 1980 to that in 1982?
Keep it short and to the point. 0.98. What is the ratio of the General Parity Index (GPI) of Mongolia in 1980 to that in 1982?
Give a very brief answer. 0.98. What is the ratio of the General Parity Index (GPI) of New Zealand in 1980 to that in 1982?
Provide a short and direct response. 1.01. What is the ratio of the General Parity Index (GPI) of Kiribati in 1980 to that in 1983?
Keep it short and to the point. 0.98. What is the ratio of the General Parity Index (GPI) in Luxembourg in 1980 to that in 1983?
Ensure brevity in your answer.  1.01. What is the ratio of the General Parity Index (GPI) of Mongolia in 1980 to that in 1983?
Offer a terse response. 0.97. What is the ratio of the General Parity Index (GPI) of New Zealand in 1980 to that in 1983?
Make the answer very short. 1.01. What is the ratio of the General Parity Index (GPI) in Kiribati in 1980 to that in 1984?
Offer a terse response. 0.98. What is the ratio of the General Parity Index (GPI) in Luxembourg in 1980 to that in 1984?
Provide a short and direct response. 1. What is the ratio of the General Parity Index (GPI) in Mongolia in 1980 to that in 1984?
Your answer should be compact. 0.98. What is the ratio of the General Parity Index (GPI) in Kiribati in 1981 to that in 1982?
Give a very brief answer. 1. What is the ratio of the General Parity Index (GPI) in Mongolia in 1981 to that in 1982?
Give a very brief answer. 0.98. What is the ratio of the General Parity Index (GPI) of Kiribati in 1981 to that in 1983?
Keep it short and to the point. 1. What is the ratio of the General Parity Index (GPI) of Luxembourg in 1981 to that in 1983?
Keep it short and to the point. 1. What is the ratio of the General Parity Index (GPI) in Mongolia in 1981 to that in 1983?
Give a very brief answer. 0.97. What is the ratio of the General Parity Index (GPI) in Mongolia in 1981 to that in 1984?
Ensure brevity in your answer.  0.99. What is the ratio of the General Parity Index (GPI) in New Zealand in 1981 to that in 1984?
Offer a very short reply. 1. What is the ratio of the General Parity Index (GPI) of Luxembourg in 1982 to that in 1983?
Offer a terse response. 1.01. What is the ratio of the General Parity Index (GPI) in Kiribati in 1982 to that in 1984?
Ensure brevity in your answer.  1. What is the ratio of the General Parity Index (GPI) of Luxembourg in 1982 to that in 1984?
Provide a short and direct response. 1.01. What is the ratio of the General Parity Index (GPI) of New Zealand in 1982 to that in 1984?
Give a very brief answer. 0.99. What is the ratio of the General Parity Index (GPI) in Kiribati in 1983 to that in 1984?
Provide a short and direct response. 1. What is the ratio of the General Parity Index (GPI) in Mongolia in 1983 to that in 1984?
Your answer should be compact. 1.02. What is the difference between the highest and the second highest General Parity Index (GPI) of Kiribati?
Offer a terse response. 0. What is the difference between the highest and the second highest General Parity Index (GPI) in Luxembourg?
Provide a succinct answer. 0.01. What is the difference between the highest and the second highest General Parity Index (GPI) in Mongolia?
Provide a succinct answer. 0. What is the difference between the highest and the second highest General Parity Index (GPI) in New Zealand?
Your response must be concise. 0. What is the difference between the highest and the lowest General Parity Index (GPI) in Kiribati?
Your answer should be very brief. 0.03. What is the difference between the highest and the lowest General Parity Index (GPI) in Luxembourg?
Offer a very short reply. 0.02. What is the difference between the highest and the lowest General Parity Index (GPI) of Mongolia?
Your answer should be compact. 0.03. What is the difference between the highest and the lowest General Parity Index (GPI) in New Zealand?
Give a very brief answer. 0.01. 